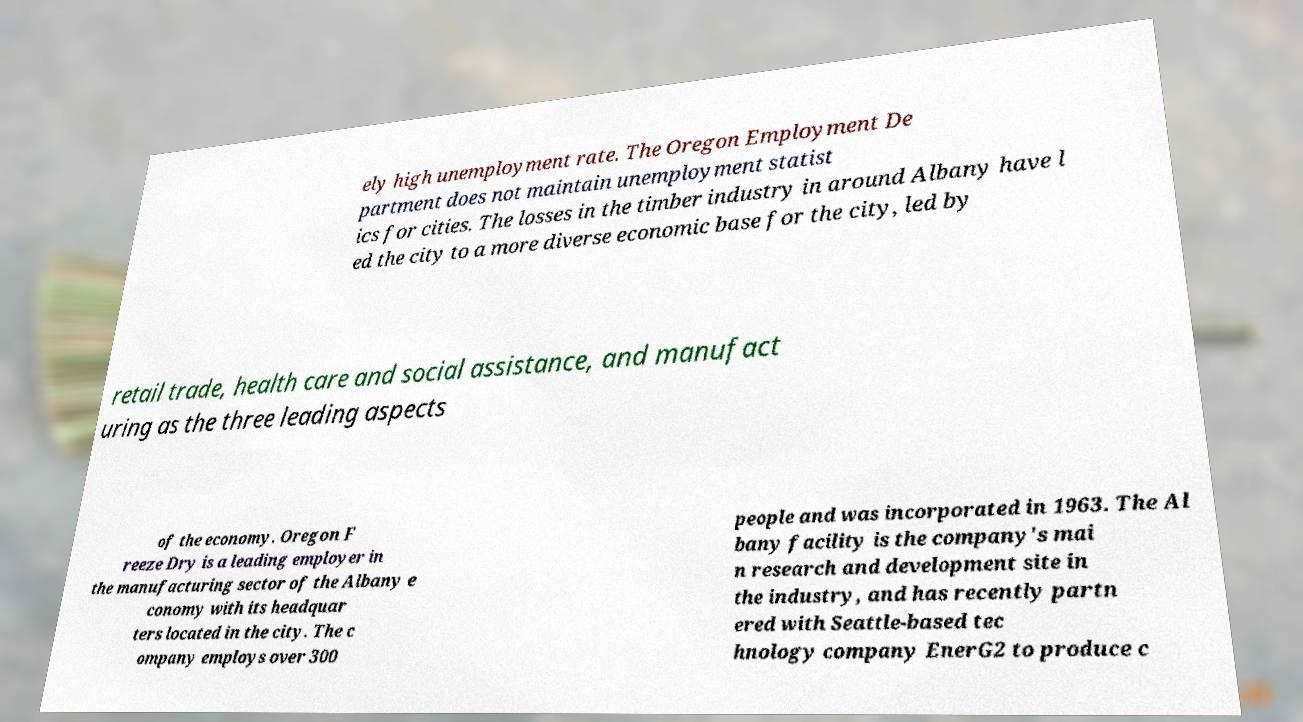For documentation purposes, I need the text within this image transcribed. Could you provide that? ely high unemployment rate. The Oregon Employment De partment does not maintain unemployment statist ics for cities. The losses in the timber industry in around Albany have l ed the city to a more diverse economic base for the city, led by retail trade, health care and social assistance, and manufact uring as the three leading aspects of the economy. Oregon F reeze Dry is a leading employer in the manufacturing sector of the Albany e conomy with its headquar ters located in the city. The c ompany employs over 300 people and was incorporated in 1963. The Al bany facility is the company's mai n research and development site in the industry, and has recently partn ered with Seattle-based tec hnology company EnerG2 to produce c 